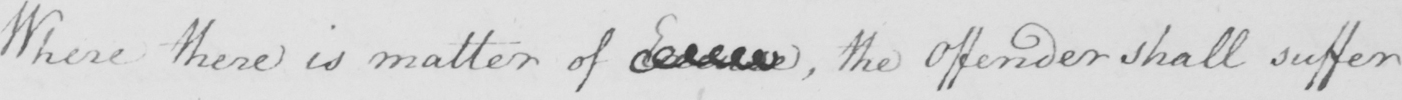Please provide the text content of this handwritten line. Where there is matter of Excuse  , the Offender shall suffer 